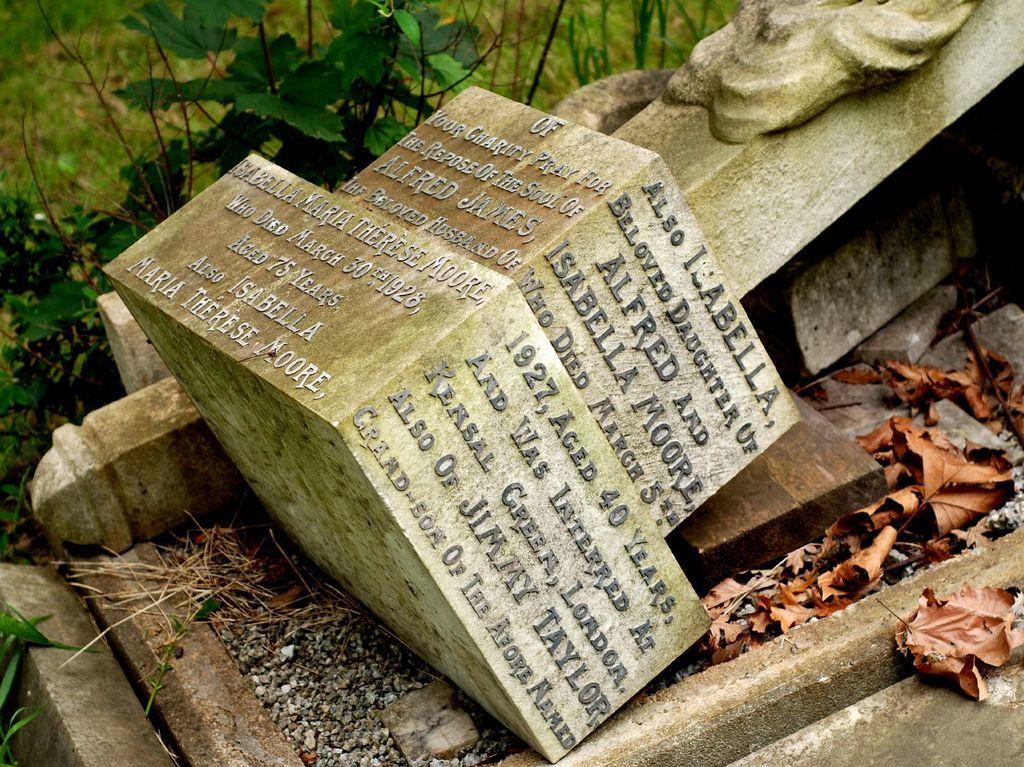How would you summarize this image in a sentence or two? In the center of the image a statue is there. On the right side of the image we can see dry leaves are there. At the top of the image we can see some plants, ground are there. 